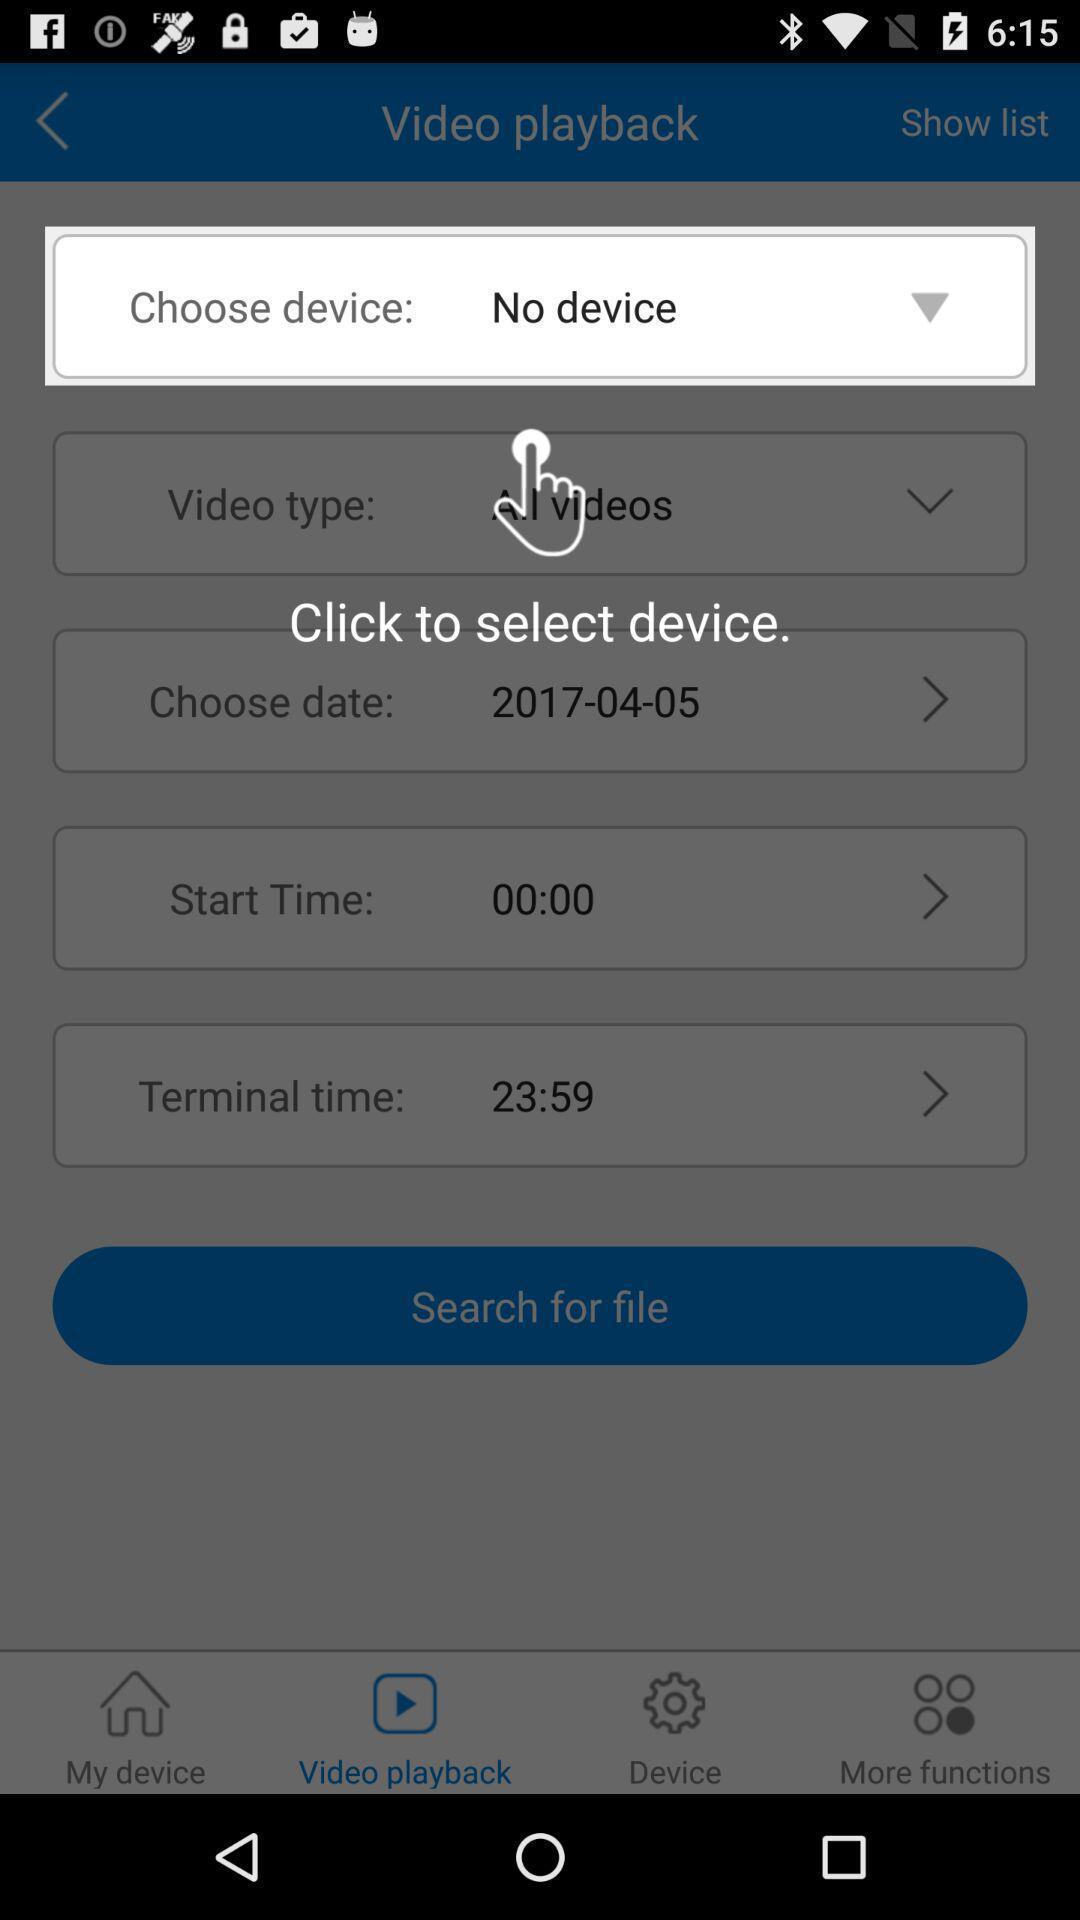Summarize the information in this screenshot. Popup to select in the video app. 